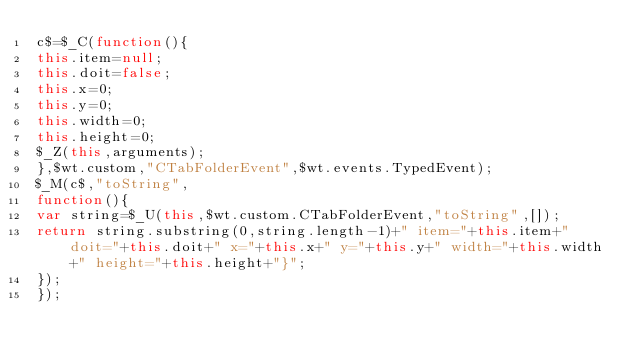Convert code to text. <code><loc_0><loc_0><loc_500><loc_500><_JavaScript_>c$=$_C(function(){
this.item=null;
this.doit=false;
this.x=0;
this.y=0;
this.width=0;
this.height=0;
$_Z(this,arguments);
},$wt.custom,"CTabFolderEvent",$wt.events.TypedEvent);
$_M(c$,"toString",
function(){
var string=$_U(this,$wt.custom.CTabFolderEvent,"toString",[]);
return string.substring(0,string.length-1)+" item="+this.item+" doit="+this.doit+" x="+this.x+" y="+this.y+" width="+this.width+" height="+this.height+"}";
});
});
</code> 